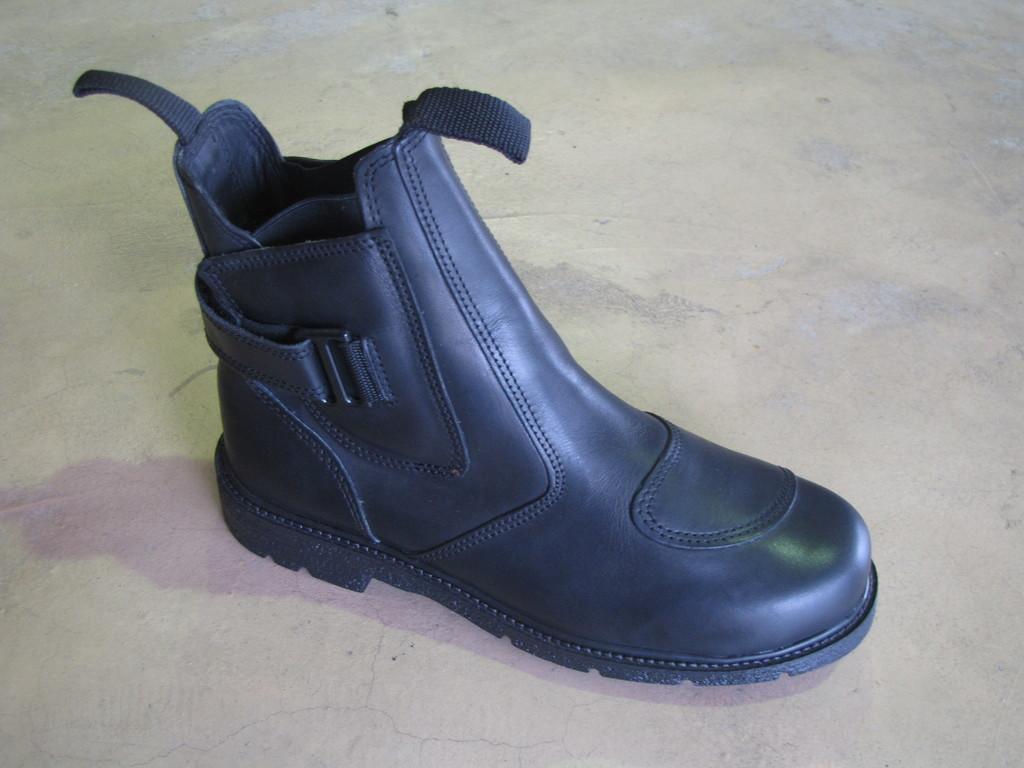Can you describe this image briefly? In this picture, there is a shoe on the floor. It is in black in color. 